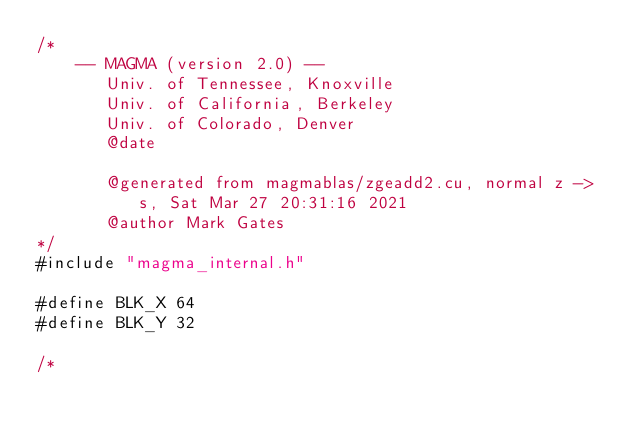<code> <loc_0><loc_0><loc_500><loc_500><_Cuda_>/*
    -- MAGMA (version 2.0) --
       Univ. of Tennessee, Knoxville
       Univ. of California, Berkeley
       Univ. of Colorado, Denver
       @date

       @generated from magmablas/zgeadd2.cu, normal z -> s, Sat Mar 27 20:31:16 2021
       @author Mark Gates
*/
#include "magma_internal.h"

#define BLK_X 64
#define BLK_Y 32

/*</code> 